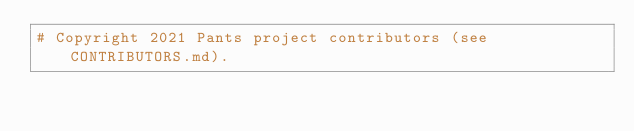Convert code to text. <code><loc_0><loc_0><loc_500><loc_500><_Python_># Copyright 2021 Pants project contributors (see CONTRIBUTORS.md).</code> 